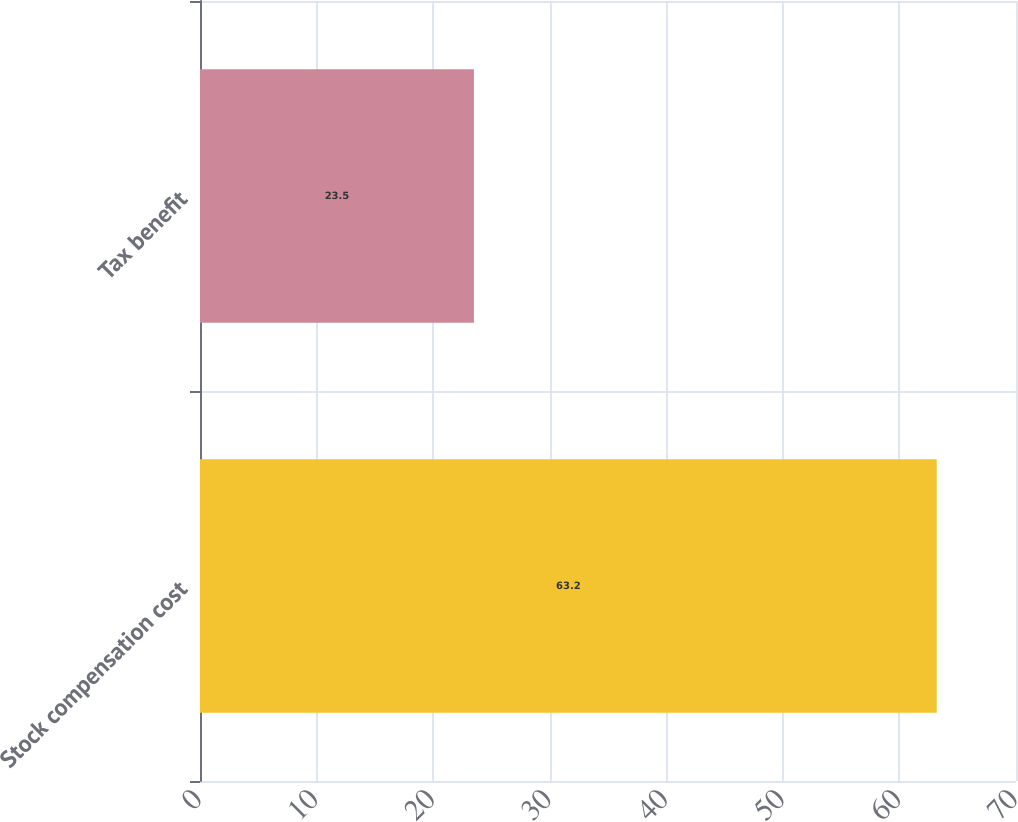Convert chart. <chart><loc_0><loc_0><loc_500><loc_500><bar_chart><fcel>Stock compensation cost<fcel>Tax benefit<nl><fcel>63.2<fcel>23.5<nl></chart> 